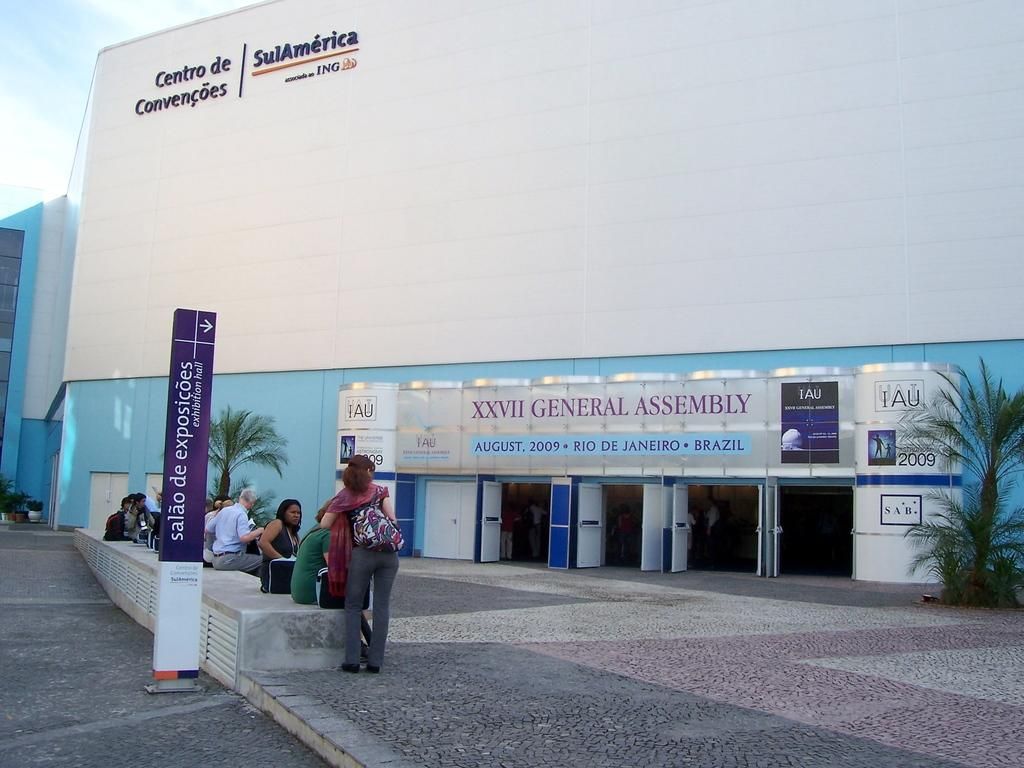What are the people in the image doing? The people in the image are sitting on the floor. What can be seen in the background behind the people? There are buildings in front of the people. What is located in front of the buildings? There are plants in front of the buildings. How does the image show an increase in productivity? The image does not show an increase in productivity, as it only depicts people sitting on the floor and the surrounding environment. 